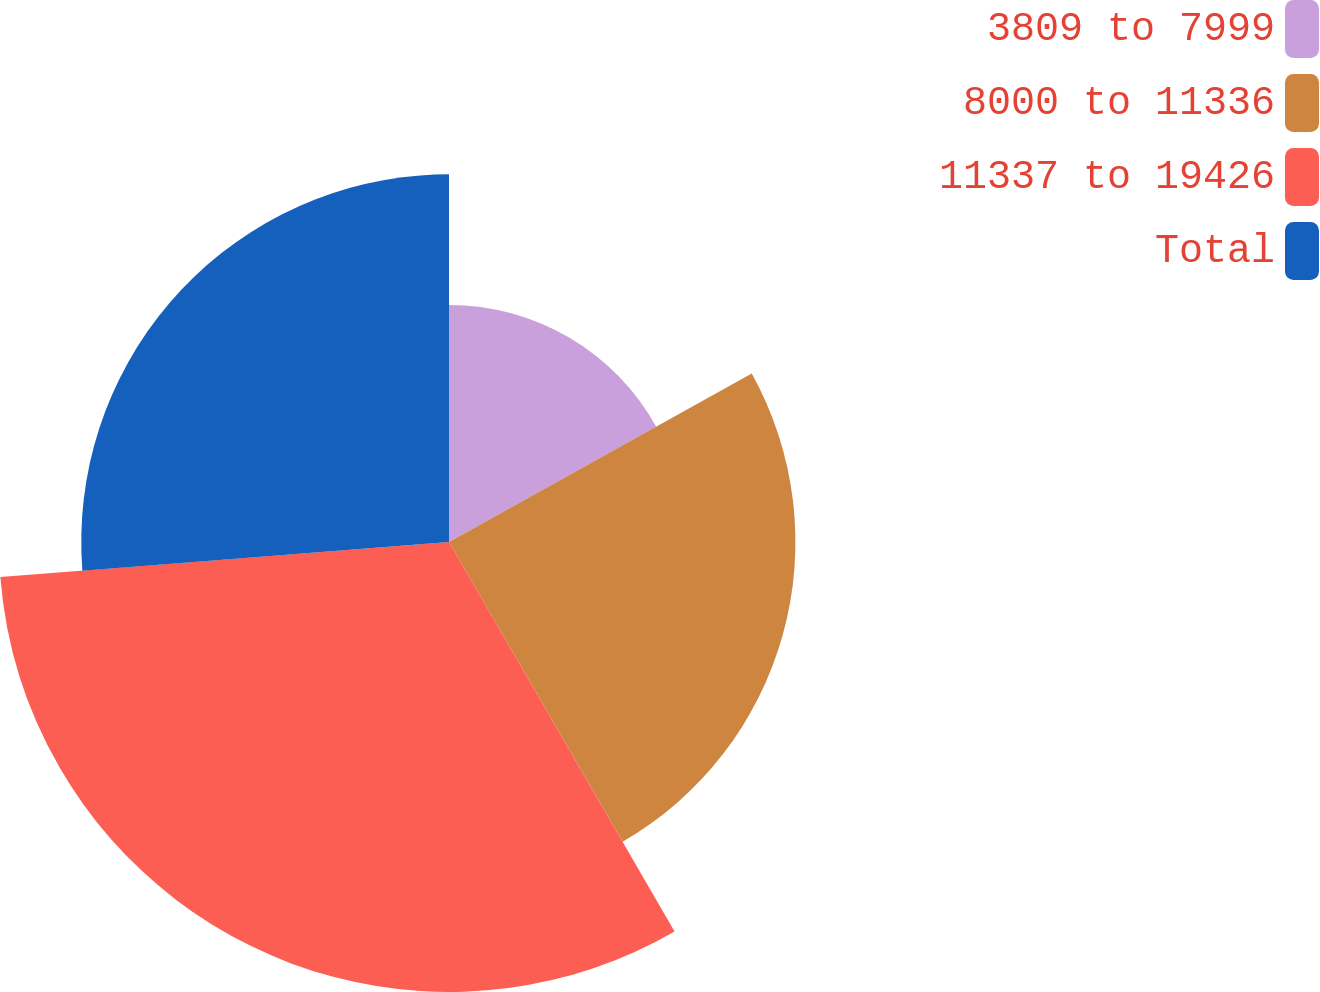Convert chart to OTSL. <chart><loc_0><loc_0><loc_500><loc_500><pie_chart><fcel>3809 to 7999<fcel>8000 to 11336<fcel>11337 to 19426<fcel>Total<nl><fcel>16.92%<fcel>24.72%<fcel>32.11%<fcel>26.24%<nl></chart> 